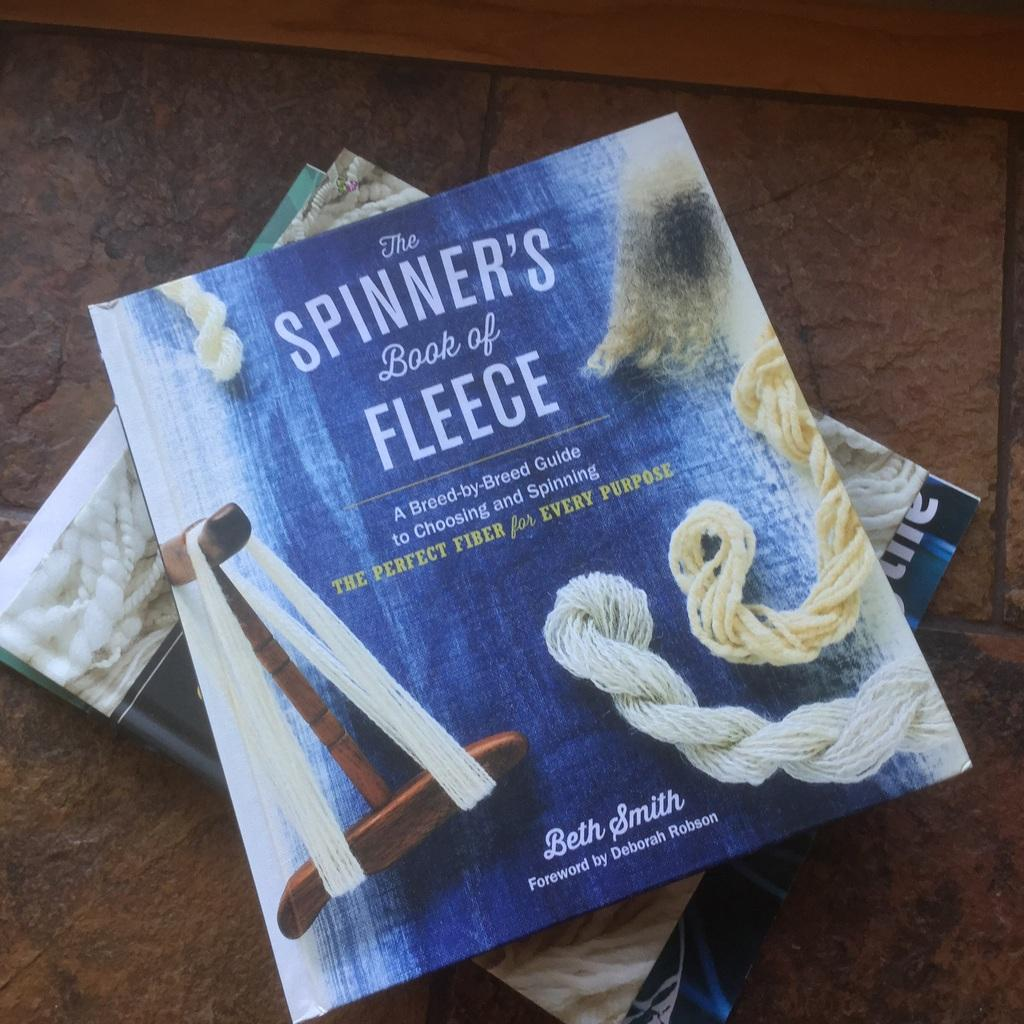<image>
Share a concise interpretation of the image provided. The spinners book of Fleece stacked upon other books. 